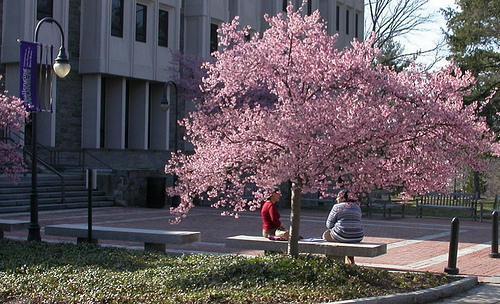How many benches are there?
Give a very brief answer. 2. 